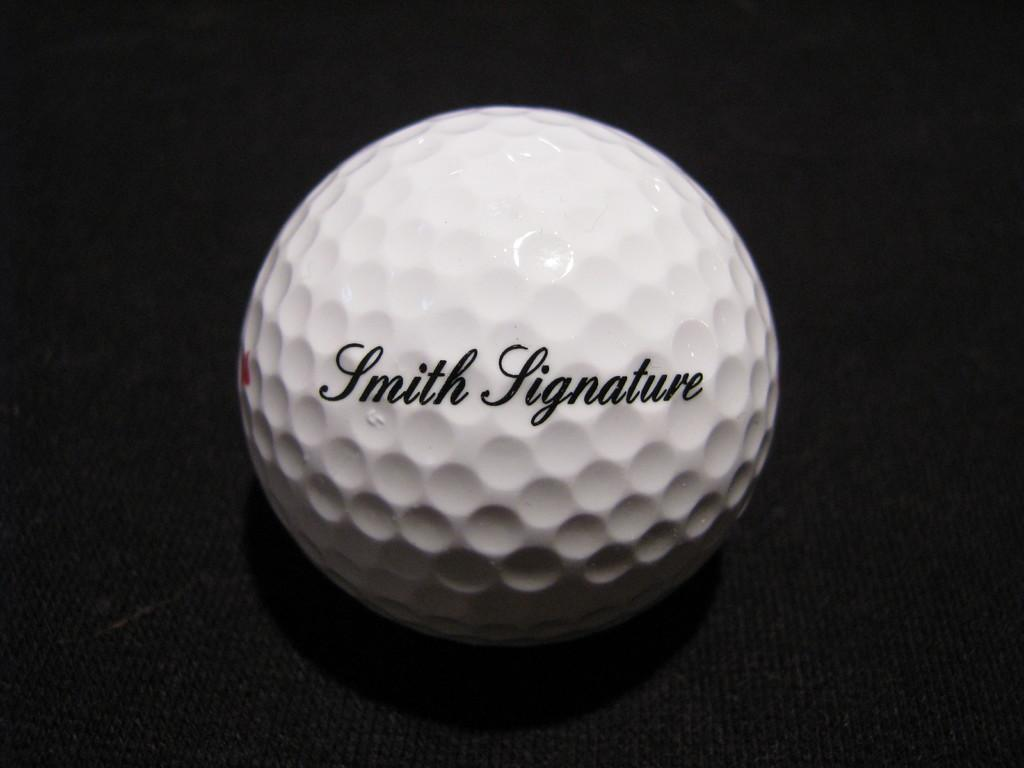What is the main object in the image? There is a white ball in the image. What is the white ball resting on? The white ball is on a black object. What text is visible on the white ball? The phrase "Smith Signature" is written on the white ball. How many feet are visible in the image? There are no feet visible in the image. What type of tent is set up in the background of the image? There is no tent present in the image. 